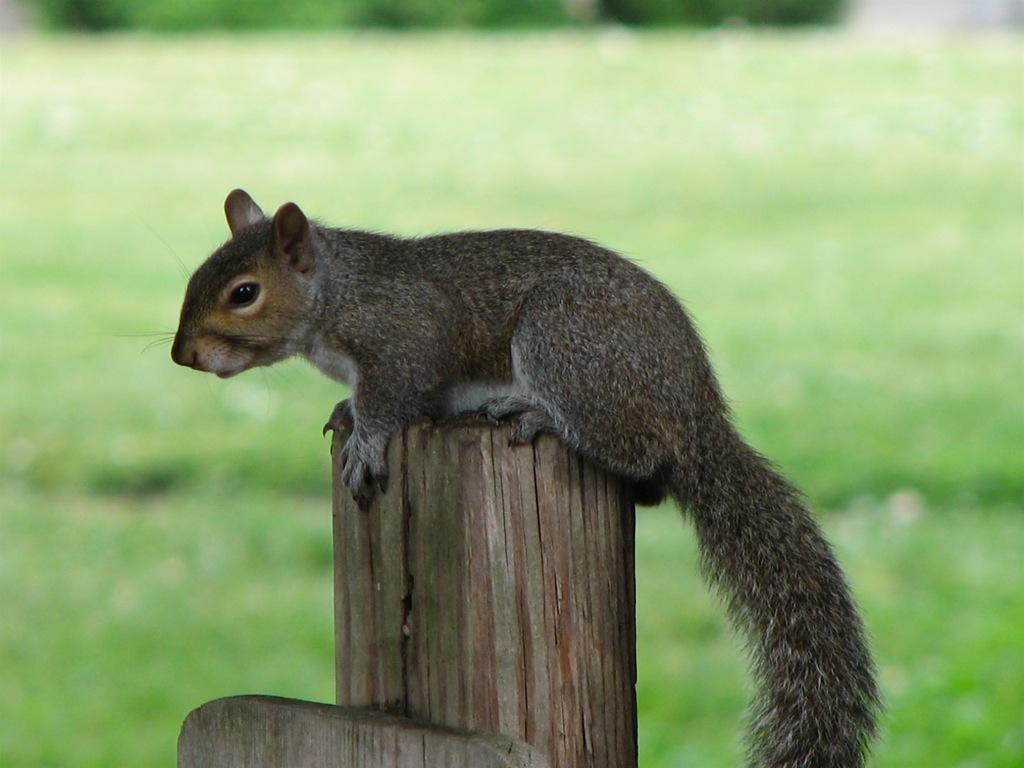What animal can be seen in the image? There is a squirrel in the image. What is the squirrel standing on? The squirrel is on a wooden stick. Can you describe the background of the image? The background of the image is blurred. What type of vegetation is visible in the background? There is greenery visible in the background. What type of underwear is the squirrel wearing in the image? There is no underwear present in the image, as it features a squirrel on a wooden stick with a blurred background. 